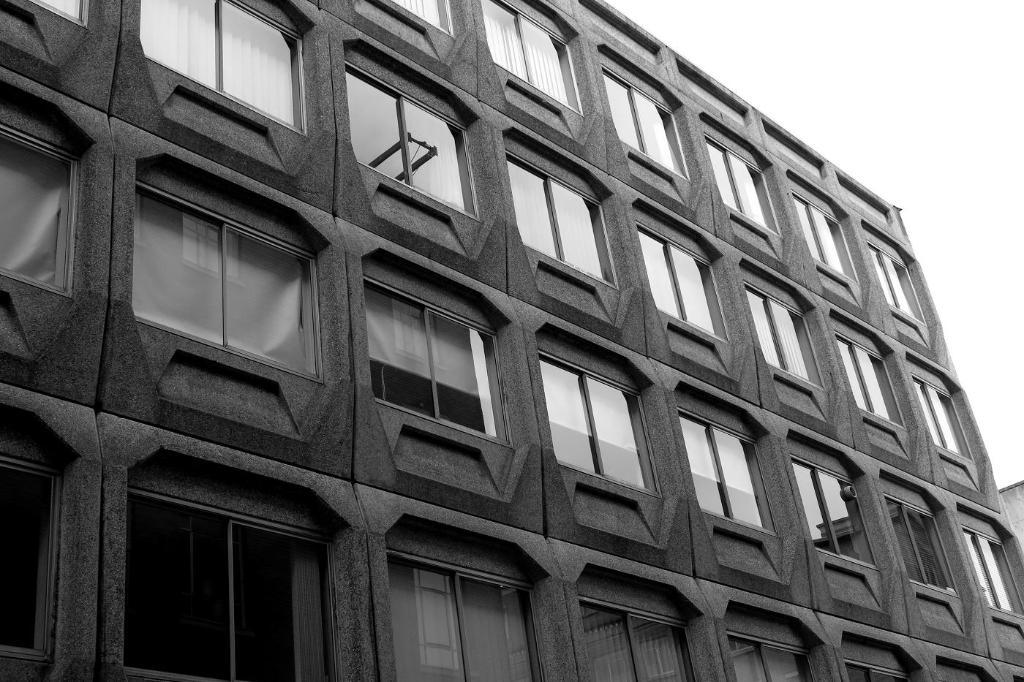What is the color scheme of the image? The image is black and white. What type of structure can be seen in the image? There is a building in the image. What part of the natural environment is visible in the image? The sky is visible in the background of the image. Can you see a family enjoying a picnic in the park in the image? There is no park or family present in the image; it features a black and white image of a building with the sky visible in the background. 